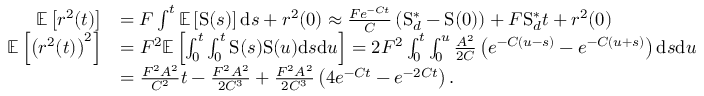<formula> <loc_0><loc_0><loc_500><loc_500>\begin{array} { r l } { \mathbb { E } \left [ r ^ { 2 } ( t ) \right ] } & { = F \int ^ { t } \mathbb { E } \left [ S ( s ) \right ] d s + r ^ { 2 } ( 0 ) \approx \frac { F e ^ { - C t } } { C } \left ( S _ { d } ^ { \ast } - S ( 0 ) \right ) + F S _ { d } ^ { \ast } t + r ^ { 2 } ( 0 ) } \\ { \mathbb { E } \left [ \left ( r ^ { 2 } ( t ) \right ) ^ { 2 } \right ] } & { = F ^ { 2 } \mathbb { E } \left [ \int _ { 0 } ^ { t } \int _ { 0 } ^ { t } S ( s ) S ( u ) d s d u \right ] = 2 F ^ { 2 } \int _ { 0 } ^ { t } \int _ { 0 } ^ { u } \frac { A ^ { 2 } } { 2 C } \left ( e ^ { - C ( u - s ) } - e ^ { - C ( u + s ) } \right ) d s d u } \\ & { = \frac { F ^ { 2 } A ^ { 2 } } { C ^ { 2 } } t - \frac { F ^ { 2 } A ^ { 2 } } { 2 C ^ { 3 } } + \frac { F ^ { 2 } A ^ { 2 } } { 2 C ^ { 3 } } \left ( 4 e ^ { - C t } - e ^ { - 2 C t } \right ) . } \end{array}</formula> 